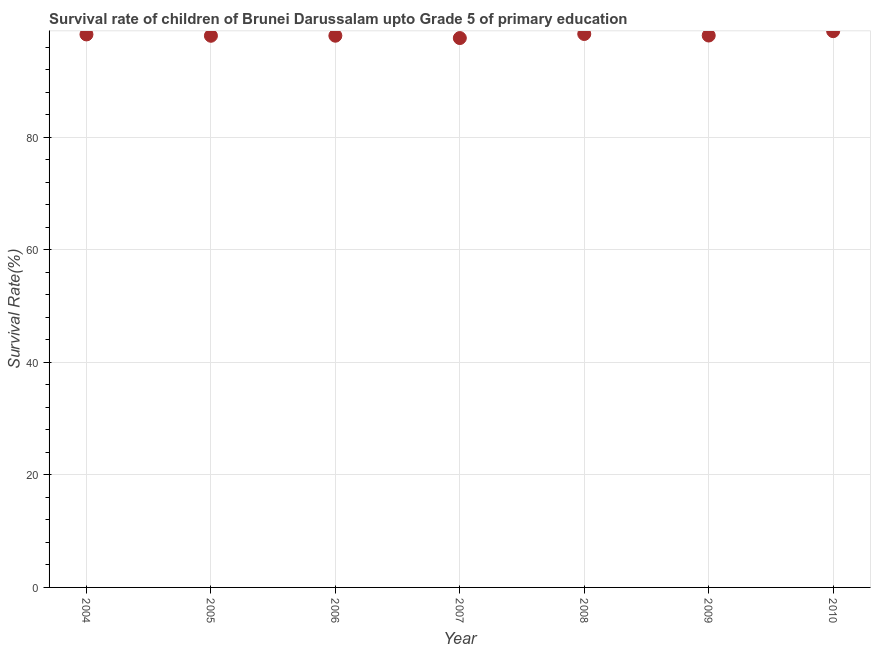What is the survival rate in 2010?
Keep it short and to the point. 98.84. Across all years, what is the maximum survival rate?
Give a very brief answer. 98.84. Across all years, what is the minimum survival rate?
Your answer should be very brief. 97.62. In which year was the survival rate maximum?
Give a very brief answer. 2010. What is the sum of the survival rate?
Give a very brief answer. 687.19. What is the difference between the survival rate in 2006 and 2008?
Your answer should be compact. -0.31. What is the average survival rate per year?
Make the answer very short. 98.17. What is the median survival rate?
Ensure brevity in your answer.  98.07. What is the ratio of the survival rate in 2009 to that in 2010?
Give a very brief answer. 0.99. Is the survival rate in 2004 less than that in 2010?
Ensure brevity in your answer.  Yes. Is the difference between the survival rate in 2004 and 2010 greater than the difference between any two years?
Your answer should be very brief. No. What is the difference between the highest and the second highest survival rate?
Offer a terse response. 0.5. What is the difference between the highest and the lowest survival rate?
Give a very brief answer. 1.22. Does the survival rate monotonically increase over the years?
Your answer should be very brief. No. What is the difference between two consecutive major ticks on the Y-axis?
Your answer should be compact. 20. Are the values on the major ticks of Y-axis written in scientific E-notation?
Provide a succinct answer. No. Does the graph contain grids?
Keep it short and to the point. Yes. What is the title of the graph?
Offer a very short reply. Survival rate of children of Brunei Darussalam upto Grade 5 of primary education. What is the label or title of the X-axis?
Offer a very short reply. Year. What is the label or title of the Y-axis?
Your answer should be very brief. Survival Rate(%). What is the Survival Rate(%) in 2004?
Keep it short and to the point. 98.26. What is the Survival Rate(%) in 2005?
Make the answer very short. 98.03. What is the Survival Rate(%) in 2006?
Your answer should be compact. 98.03. What is the Survival Rate(%) in 2007?
Ensure brevity in your answer.  97.62. What is the Survival Rate(%) in 2008?
Keep it short and to the point. 98.34. What is the Survival Rate(%) in 2009?
Your answer should be compact. 98.07. What is the Survival Rate(%) in 2010?
Offer a terse response. 98.84. What is the difference between the Survival Rate(%) in 2004 and 2005?
Ensure brevity in your answer.  0.24. What is the difference between the Survival Rate(%) in 2004 and 2006?
Provide a short and direct response. 0.23. What is the difference between the Survival Rate(%) in 2004 and 2007?
Your response must be concise. 0.64. What is the difference between the Survival Rate(%) in 2004 and 2008?
Offer a terse response. -0.08. What is the difference between the Survival Rate(%) in 2004 and 2009?
Provide a short and direct response. 0.19. What is the difference between the Survival Rate(%) in 2004 and 2010?
Provide a short and direct response. -0.58. What is the difference between the Survival Rate(%) in 2005 and 2006?
Your response must be concise. -0.01. What is the difference between the Survival Rate(%) in 2005 and 2007?
Ensure brevity in your answer.  0.41. What is the difference between the Survival Rate(%) in 2005 and 2008?
Your answer should be compact. -0.32. What is the difference between the Survival Rate(%) in 2005 and 2009?
Ensure brevity in your answer.  -0.04. What is the difference between the Survival Rate(%) in 2005 and 2010?
Ensure brevity in your answer.  -0.82. What is the difference between the Survival Rate(%) in 2006 and 2007?
Provide a short and direct response. 0.42. What is the difference between the Survival Rate(%) in 2006 and 2008?
Provide a short and direct response. -0.31. What is the difference between the Survival Rate(%) in 2006 and 2009?
Make the answer very short. -0.03. What is the difference between the Survival Rate(%) in 2006 and 2010?
Offer a terse response. -0.81. What is the difference between the Survival Rate(%) in 2007 and 2008?
Provide a succinct answer. -0.72. What is the difference between the Survival Rate(%) in 2007 and 2009?
Your response must be concise. -0.45. What is the difference between the Survival Rate(%) in 2007 and 2010?
Your response must be concise. -1.22. What is the difference between the Survival Rate(%) in 2008 and 2009?
Make the answer very short. 0.27. What is the difference between the Survival Rate(%) in 2008 and 2010?
Your answer should be very brief. -0.5. What is the difference between the Survival Rate(%) in 2009 and 2010?
Your answer should be very brief. -0.77. What is the ratio of the Survival Rate(%) in 2004 to that in 2005?
Provide a succinct answer. 1. What is the ratio of the Survival Rate(%) in 2004 to that in 2006?
Your answer should be very brief. 1. What is the ratio of the Survival Rate(%) in 2004 to that in 2007?
Offer a terse response. 1.01. What is the ratio of the Survival Rate(%) in 2005 to that in 2008?
Offer a very short reply. 1. What is the ratio of the Survival Rate(%) in 2005 to that in 2009?
Your response must be concise. 1. What is the ratio of the Survival Rate(%) in 2005 to that in 2010?
Ensure brevity in your answer.  0.99. What is the ratio of the Survival Rate(%) in 2006 to that in 2008?
Your answer should be compact. 1. What is the ratio of the Survival Rate(%) in 2006 to that in 2010?
Offer a terse response. 0.99. What is the ratio of the Survival Rate(%) in 2007 to that in 2008?
Your answer should be very brief. 0.99. What is the ratio of the Survival Rate(%) in 2008 to that in 2009?
Offer a terse response. 1. What is the ratio of the Survival Rate(%) in 2009 to that in 2010?
Offer a terse response. 0.99. 